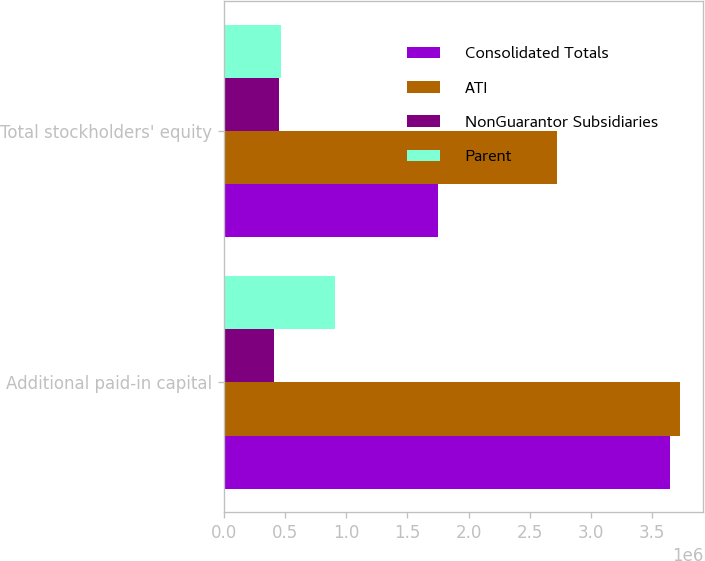Convert chart to OTSL. <chart><loc_0><loc_0><loc_500><loc_500><stacked_bar_chart><ecel><fcel>Additional paid-in capital<fcel>Total stockholders' equity<nl><fcel>Consolidated Totals<fcel>3.64202e+06<fcel>1.75261e+06<nl><fcel>ATI<fcel>3.72982e+06<fcel>2.72141e+06<nl><fcel>NonGuarantor Subsidiaries<fcel>414037<fcel>451940<nl><fcel>Parent<fcel>911202<fcel>465559<nl></chart> 